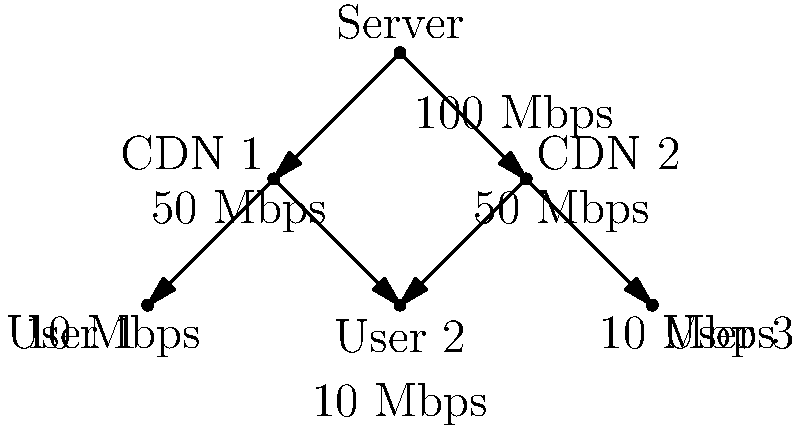Given the network diagram for your Bollywood dance tutorial video streaming service, what is the maximum number of simultaneous users that can be supported at full quality (10 Mbps per user) without overloading any part of the network? To determine the maximum number of simultaneous users at full quality, we need to analyze the network diagram and identify the bottleneck:

1. The server has a 100 Mbps connection, split equally between two Content Delivery Networks (CDNs).
2. Each CDN has a 50 Mbps connection.
3. Users require 10 Mbps each for full quality streaming.

Let's calculate the capacity at each level:

1. Server level: 100 Mbps ÷ 10 Mbps = 10 users
2. CDN level: 50 Mbps ÷ 10 Mbps = 5 users per CDN

The bottleneck is at the CDN level. Each CDN can support 5 users, and there are two CDNs.

Therefore, the maximum number of simultaneous users at full quality is:

$$5 \text{ users/CDN} \times 2 \text{ CDNs} = 10 \text{ users}$$

This matches the server's capacity, ensuring no overload at any point in the network.
Answer: 10 users 